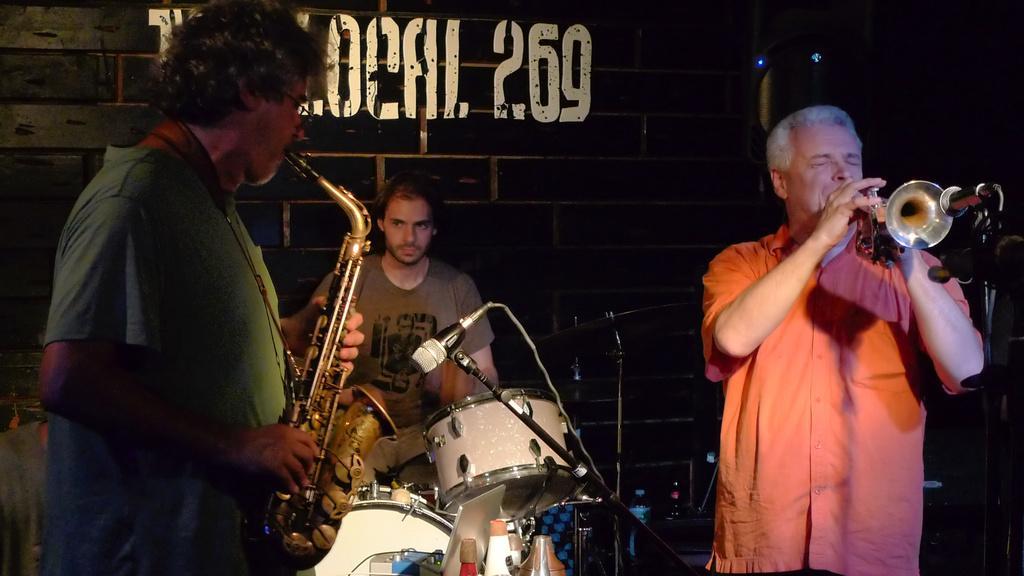Could you give a brief overview of what you see in this image? In this image, we can see three people are playing musical instruments. Here we can see microphones with stand and wire. Background there is a wall, some text and black color object here. At the bottom of the image, we can see few bottles. 